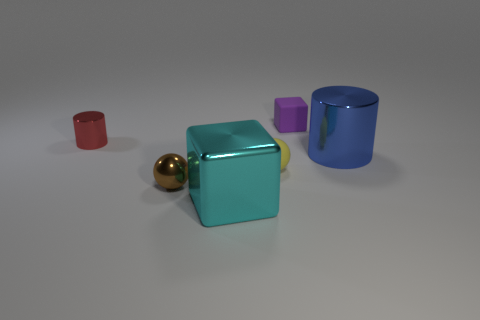Subtract 1 cylinders. How many cylinders are left? 1 Add 2 purple matte blocks. How many objects exist? 8 Subtract all yellow balls. How many red cubes are left? 0 Subtract all red cylinders. Subtract all big cylinders. How many objects are left? 4 Add 3 large cyan things. How many large cyan things are left? 4 Add 4 large cyan shiny blocks. How many large cyan shiny blocks exist? 5 Subtract 0 green cubes. How many objects are left? 6 Subtract all blue cylinders. Subtract all gray spheres. How many cylinders are left? 1 